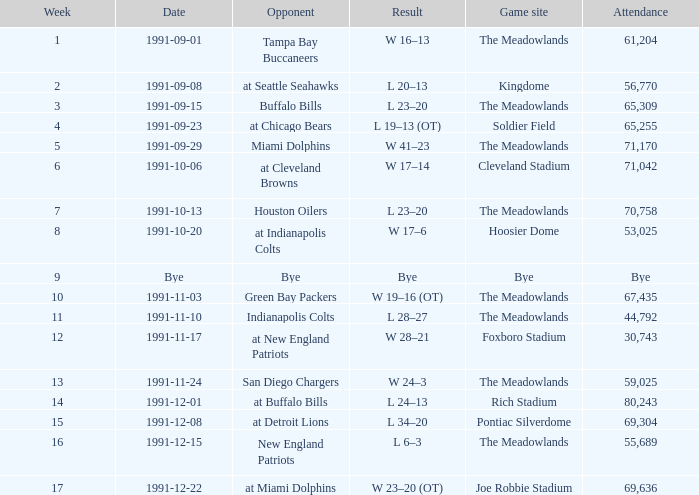How many people attended in week 17? 69636.0. 